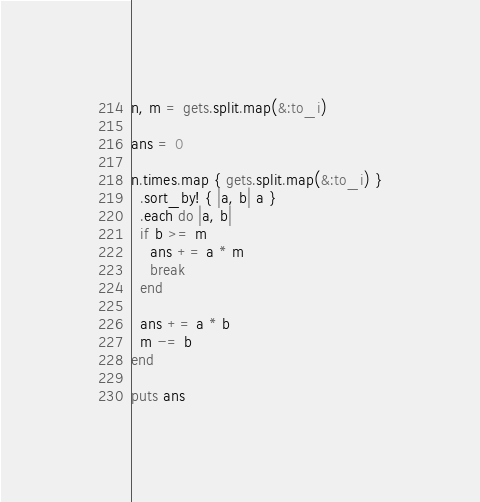<code> <loc_0><loc_0><loc_500><loc_500><_Ruby_>n, m = gets.split.map(&:to_i)

ans = 0

n.times.map { gets.split.map(&:to_i) }
  .sort_by! { |a, b| a }
  .each do |a, b|
  if b >= m
    ans += a * m
    break
  end

  ans += a * b
  m -= b
end

puts ans
</code> 